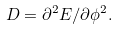<formula> <loc_0><loc_0><loc_500><loc_500>D = \partial ^ { 2 } E / \partial \phi ^ { 2 } .</formula> 